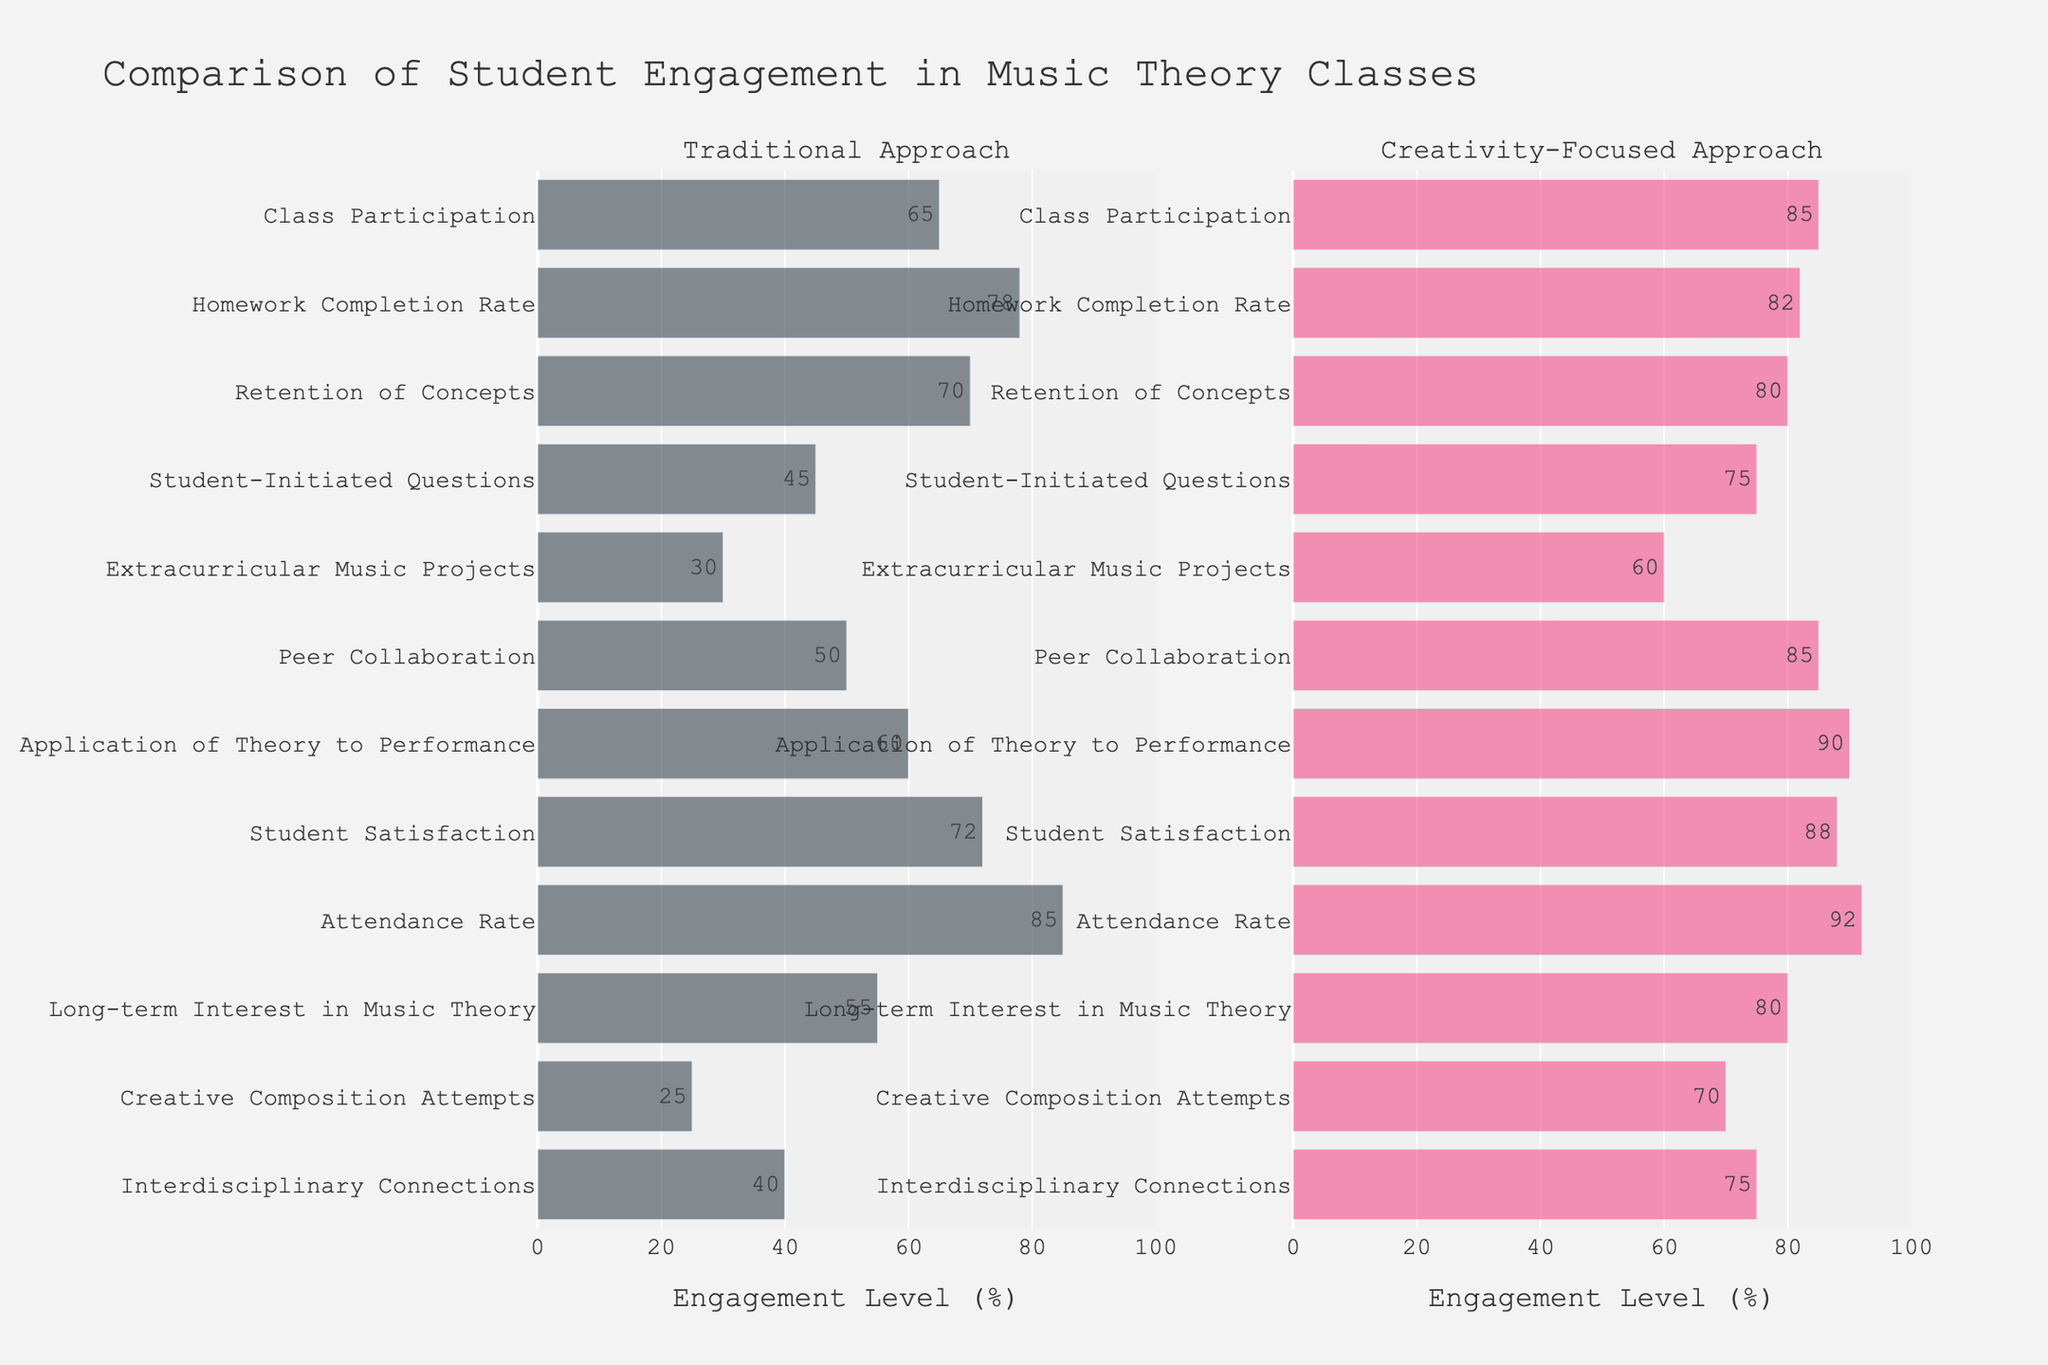Which approach has the highest student satisfaction? Compare the bar heights for "Student Satisfaction" in both approaches. The Creativity-Focused Approach has a taller bar.
Answer: Creativity-Focused Approach What is the difference in class participation between the two approaches? Subtract the Traditional Approach value from the Creativity-Focused Approach value for "Class Participation" (85 - 65).
Answer: 20 In which category do we see the largest gap between the two approaches? Find the category with the highest difference by subtracting values for each category. "Creative Composition Attempts" has the largest gap (70 - 25 = 45).
Answer: Creative Composition Attempts How many percentage points higher is the attendance rate in the Creativity-Focused Approach compared to the Traditional Approach? Subtract the Traditional Approach value from the Creativity-Focused Approach value for "Attendance Rate" (92 - 85).
Answer: 7 What is the average retention of concepts across both approaches? Add both values for "Retention of Concepts" and divide by 2 ((70 + 80) / 2).
Answer: 75 Which approach shows a greater level of peer collaboration? Compare the bar heights for "Peer Collaboration" in both approaches. The Creativity-Focused Approach has a taller bar.
Answer: Creativity-Focused Approach Is the homework completion rate higher in the Traditional or Creativity-Focused Approach? Compare the bar heights for "Homework Completion Rate" in both approaches. The Creativity-Focused Approach has a slightly taller bar.
Answer: Creativity-Focused Approach What is the median engagement level for the Creativity-Focused Approach? Arrange all values for Creativity-Focused Approach in numerical order, the median is the middle value in the ordered list (90 + 85 + 85 + 82 + 80 + 75 + 75 + 70 + 70 + 60 + 60 + 55,  in the order 55, 60, 60, 70, 70, 75, 75, 80, 82, 85, 85, 90, the median is (75 + 75) / 2).
Answer: 75 Which criteria show equal or greater engagement level in the Creativity-Focused Approach compared to 75%? Identify bars for Creativity-Focused Approach equal to or taller than the 75% mark: "Class Participation," "Retention of Concepts," "Student-Initiated Questions," "Extracurricular Music Projects," "Peer Collaboration," "Application of Theory to Performance," "Student Satisfaction," "Attendance Rate," "Long-term Interest in Music Theory," "Interdisciplinary Connections".
Answer: Class Participation, Retention of Concepts, Student-Initiated Questions, Extracurricular Music Projects, Peer Collaboration, Application of Theory to Performance, Student Satisfaction, Attendance Rate, Long-term Interest in Music Theory, Interdisciplinary Connections 